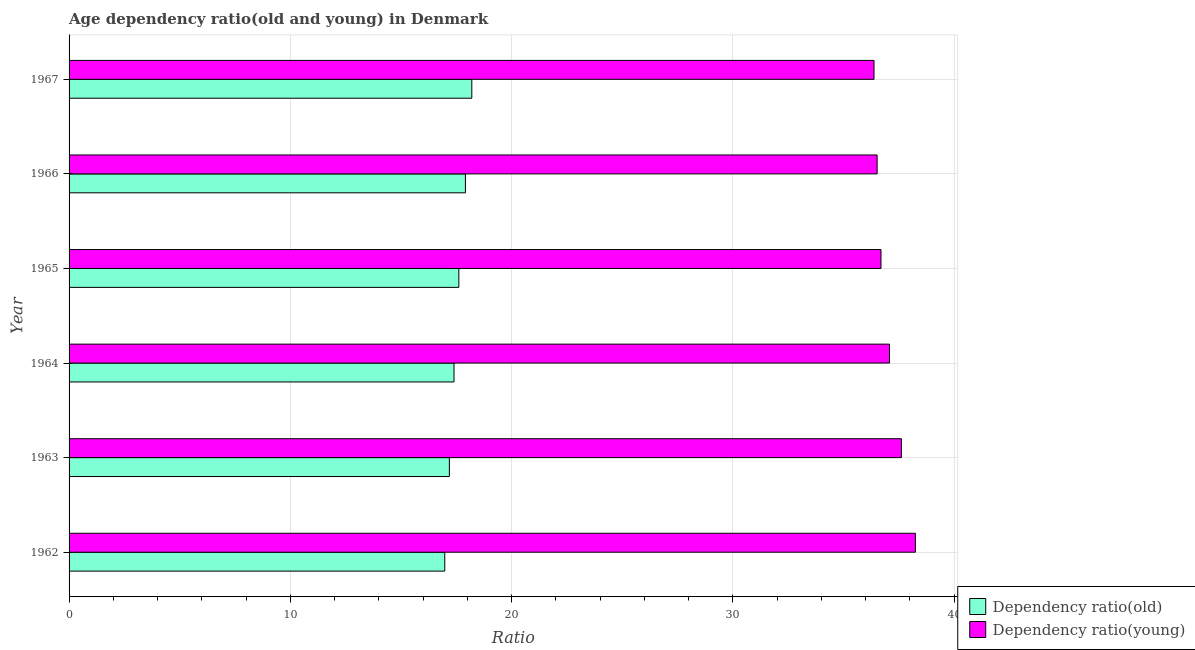Are the number of bars per tick equal to the number of legend labels?
Keep it short and to the point. Yes. Are the number of bars on each tick of the Y-axis equal?
Your answer should be compact. Yes. How many bars are there on the 5th tick from the top?
Give a very brief answer. 2. How many bars are there on the 3rd tick from the bottom?
Provide a short and direct response. 2. What is the label of the 6th group of bars from the top?
Ensure brevity in your answer.  1962. In how many cases, is the number of bars for a given year not equal to the number of legend labels?
Ensure brevity in your answer.  0. What is the age dependency ratio(young) in 1967?
Provide a succinct answer. 36.38. Across all years, what is the maximum age dependency ratio(old)?
Make the answer very short. 18.2. Across all years, what is the minimum age dependency ratio(old)?
Ensure brevity in your answer.  16.98. In which year was the age dependency ratio(old) maximum?
Make the answer very short. 1967. In which year was the age dependency ratio(old) minimum?
Offer a very short reply. 1962. What is the total age dependency ratio(old) in the graph?
Provide a short and direct response. 105.3. What is the difference between the age dependency ratio(young) in 1963 and that in 1965?
Your answer should be very brief. 0.92. What is the difference between the age dependency ratio(young) in 1962 and the age dependency ratio(old) in 1965?
Provide a short and direct response. 20.64. What is the average age dependency ratio(old) per year?
Your answer should be very brief. 17.55. In the year 1962, what is the difference between the age dependency ratio(young) and age dependency ratio(old)?
Provide a succinct answer. 21.27. Is the age dependency ratio(young) in 1962 less than that in 1965?
Ensure brevity in your answer.  No. Is the difference between the age dependency ratio(old) in 1963 and 1964 greater than the difference between the age dependency ratio(young) in 1963 and 1964?
Give a very brief answer. No. What is the difference between the highest and the second highest age dependency ratio(old)?
Offer a very short reply. 0.29. What is the difference between the highest and the lowest age dependency ratio(young)?
Ensure brevity in your answer.  1.87. What does the 2nd bar from the top in 1966 represents?
Your answer should be very brief. Dependency ratio(old). What does the 1st bar from the bottom in 1967 represents?
Your answer should be compact. Dependency ratio(old). How many bars are there?
Provide a succinct answer. 12. Are all the bars in the graph horizontal?
Provide a short and direct response. Yes. How many years are there in the graph?
Give a very brief answer. 6. Does the graph contain any zero values?
Keep it short and to the point. No. Where does the legend appear in the graph?
Your response must be concise. Bottom right. How many legend labels are there?
Make the answer very short. 2. How are the legend labels stacked?
Give a very brief answer. Vertical. What is the title of the graph?
Your answer should be very brief. Age dependency ratio(old and young) in Denmark. What is the label or title of the X-axis?
Keep it short and to the point. Ratio. What is the label or title of the Y-axis?
Make the answer very short. Year. What is the Ratio of Dependency ratio(old) in 1962?
Your answer should be compact. 16.98. What is the Ratio of Dependency ratio(young) in 1962?
Offer a very short reply. 38.25. What is the Ratio in Dependency ratio(old) in 1963?
Provide a succinct answer. 17.19. What is the Ratio in Dependency ratio(young) in 1963?
Your answer should be very brief. 37.62. What is the Ratio of Dependency ratio(old) in 1964?
Offer a terse response. 17.4. What is the Ratio in Dependency ratio(young) in 1964?
Offer a very short reply. 37.08. What is the Ratio of Dependency ratio(old) in 1965?
Provide a succinct answer. 17.62. What is the Ratio of Dependency ratio(young) in 1965?
Provide a succinct answer. 36.7. What is the Ratio in Dependency ratio(old) in 1966?
Keep it short and to the point. 17.91. What is the Ratio in Dependency ratio(young) in 1966?
Make the answer very short. 36.52. What is the Ratio in Dependency ratio(old) in 1967?
Your response must be concise. 18.2. What is the Ratio of Dependency ratio(young) in 1967?
Keep it short and to the point. 36.38. Across all years, what is the maximum Ratio of Dependency ratio(old)?
Provide a succinct answer. 18.2. Across all years, what is the maximum Ratio of Dependency ratio(young)?
Give a very brief answer. 38.25. Across all years, what is the minimum Ratio in Dependency ratio(old)?
Make the answer very short. 16.98. Across all years, what is the minimum Ratio in Dependency ratio(young)?
Give a very brief answer. 36.38. What is the total Ratio in Dependency ratio(old) in the graph?
Provide a succinct answer. 105.3. What is the total Ratio in Dependency ratio(young) in the graph?
Keep it short and to the point. 222.55. What is the difference between the Ratio in Dependency ratio(old) in 1962 and that in 1963?
Make the answer very short. -0.21. What is the difference between the Ratio of Dependency ratio(young) in 1962 and that in 1963?
Your answer should be compact. 0.63. What is the difference between the Ratio in Dependency ratio(old) in 1962 and that in 1964?
Make the answer very short. -0.42. What is the difference between the Ratio of Dependency ratio(young) in 1962 and that in 1964?
Offer a very short reply. 1.17. What is the difference between the Ratio of Dependency ratio(old) in 1962 and that in 1965?
Your answer should be very brief. -0.64. What is the difference between the Ratio in Dependency ratio(young) in 1962 and that in 1965?
Make the answer very short. 1.56. What is the difference between the Ratio in Dependency ratio(old) in 1962 and that in 1966?
Ensure brevity in your answer.  -0.93. What is the difference between the Ratio of Dependency ratio(young) in 1962 and that in 1966?
Ensure brevity in your answer.  1.73. What is the difference between the Ratio of Dependency ratio(old) in 1962 and that in 1967?
Give a very brief answer. -1.22. What is the difference between the Ratio of Dependency ratio(young) in 1962 and that in 1967?
Provide a short and direct response. 1.87. What is the difference between the Ratio of Dependency ratio(old) in 1963 and that in 1964?
Offer a very short reply. -0.21. What is the difference between the Ratio in Dependency ratio(young) in 1963 and that in 1964?
Provide a succinct answer. 0.54. What is the difference between the Ratio in Dependency ratio(old) in 1963 and that in 1965?
Give a very brief answer. -0.43. What is the difference between the Ratio of Dependency ratio(young) in 1963 and that in 1965?
Keep it short and to the point. 0.92. What is the difference between the Ratio of Dependency ratio(old) in 1963 and that in 1966?
Make the answer very short. -0.72. What is the difference between the Ratio of Dependency ratio(young) in 1963 and that in 1966?
Give a very brief answer. 1.1. What is the difference between the Ratio in Dependency ratio(old) in 1963 and that in 1967?
Make the answer very short. -1.01. What is the difference between the Ratio of Dependency ratio(young) in 1963 and that in 1967?
Your answer should be very brief. 1.24. What is the difference between the Ratio in Dependency ratio(old) in 1964 and that in 1965?
Your answer should be very brief. -0.22. What is the difference between the Ratio of Dependency ratio(young) in 1964 and that in 1965?
Your response must be concise. 0.39. What is the difference between the Ratio in Dependency ratio(old) in 1964 and that in 1966?
Offer a terse response. -0.52. What is the difference between the Ratio in Dependency ratio(young) in 1964 and that in 1966?
Your answer should be very brief. 0.56. What is the difference between the Ratio in Dependency ratio(old) in 1964 and that in 1967?
Provide a short and direct response. -0.8. What is the difference between the Ratio in Dependency ratio(young) in 1964 and that in 1967?
Your answer should be compact. 0.7. What is the difference between the Ratio in Dependency ratio(old) in 1965 and that in 1966?
Ensure brevity in your answer.  -0.3. What is the difference between the Ratio in Dependency ratio(young) in 1965 and that in 1966?
Your answer should be compact. 0.17. What is the difference between the Ratio in Dependency ratio(old) in 1965 and that in 1967?
Make the answer very short. -0.59. What is the difference between the Ratio of Dependency ratio(young) in 1965 and that in 1967?
Your answer should be very brief. 0.31. What is the difference between the Ratio in Dependency ratio(old) in 1966 and that in 1967?
Offer a terse response. -0.29. What is the difference between the Ratio of Dependency ratio(young) in 1966 and that in 1967?
Your response must be concise. 0.14. What is the difference between the Ratio in Dependency ratio(old) in 1962 and the Ratio in Dependency ratio(young) in 1963?
Your answer should be compact. -20.64. What is the difference between the Ratio in Dependency ratio(old) in 1962 and the Ratio in Dependency ratio(young) in 1964?
Your response must be concise. -20.1. What is the difference between the Ratio of Dependency ratio(old) in 1962 and the Ratio of Dependency ratio(young) in 1965?
Offer a very short reply. -19.72. What is the difference between the Ratio of Dependency ratio(old) in 1962 and the Ratio of Dependency ratio(young) in 1966?
Provide a short and direct response. -19.54. What is the difference between the Ratio of Dependency ratio(old) in 1962 and the Ratio of Dependency ratio(young) in 1967?
Keep it short and to the point. -19.4. What is the difference between the Ratio of Dependency ratio(old) in 1963 and the Ratio of Dependency ratio(young) in 1964?
Your answer should be compact. -19.89. What is the difference between the Ratio in Dependency ratio(old) in 1963 and the Ratio in Dependency ratio(young) in 1965?
Offer a very short reply. -19.51. What is the difference between the Ratio of Dependency ratio(old) in 1963 and the Ratio of Dependency ratio(young) in 1966?
Your answer should be very brief. -19.33. What is the difference between the Ratio of Dependency ratio(old) in 1963 and the Ratio of Dependency ratio(young) in 1967?
Your answer should be compact. -19.19. What is the difference between the Ratio of Dependency ratio(old) in 1964 and the Ratio of Dependency ratio(young) in 1965?
Provide a succinct answer. -19.3. What is the difference between the Ratio in Dependency ratio(old) in 1964 and the Ratio in Dependency ratio(young) in 1966?
Offer a very short reply. -19.12. What is the difference between the Ratio of Dependency ratio(old) in 1964 and the Ratio of Dependency ratio(young) in 1967?
Give a very brief answer. -18.98. What is the difference between the Ratio in Dependency ratio(old) in 1965 and the Ratio in Dependency ratio(young) in 1966?
Your answer should be compact. -18.91. What is the difference between the Ratio of Dependency ratio(old) in 1965 and the Ratio of Dependency ratio(young) in 1967?
Offer a terse response. -18.76. What is the difference between the Ratio of Dependency ratio(old) in 1966 and the Ratio of Dependency ratio(young) in 1967?
Ensure brevity in your answer.  -18.47. What is the average Ratio of Dependency ratio(old) per year?
Provide a succinct answer. 17.55. What is the average Ratio in Dependency ratio(young) per year?
Offer a very short reply. 37.09. In the year 1962, what is the difference between the Ratio of Dependency ratio(old) and Ratio of Dependency ratio(young)?
Your answer should be compact. -21.27. In the year 1963, what is the difference between the Ratio in Dependency ratio(old) and Ratio in Dependency ratio(young)?
Your response must be concise. -20.43. In the year 1964, what is the difference between the Ratio in Dependency ratio(old) and Ratio in Dependency ratio(young)?
Ensure brevity in your answer.  -19.68. In the year 1965, what is the difference between the Ratio in Dependency ratio(old) and Ratio in Dependency ratio(young)?
Ensure brevity in your answer.  -19.08. In the year 1966, what is the difference between the Ratio of Dependency ratio(old) and Ratio of Dependency ratio(young)?
Make the answer very short. -18.61. In the year 1967, what is the difference between the Ratio of Dependency ratio(old) and Ratio of Dependency ratio(young)?
Offer a very short reply. -18.18. What is the ratio of the Ratio of Dependency ratio(old) in 1962 to that in 1963?
Your response must be concise. 0.99. What is the ratio of the Ratio in Dependency ratio(young) in 1962 to that in 1963?
Give a very brief answer. 1.02. What is the ratio of the Ratio in Dependency ratio(old) in 1962 to that in 1964?
Provide a short and direct response. 0.98. What is the ratio of the Ratio of Dependency ratio(young) in 1962 to that in 1964?
Give a very brief answer. 1.03. What is the ratio of the Ratio in Dependency ratio(old) in 1962 to that in 1965?
Your answer should be very brief. 0.96. What is the ratio of the Ratio of Dependency ratio(young) in 1962 to that in 1965?
Offer a very short reply. 1.04. What is the ratio of the Ratio in Dependency ratio(old) in 1962 to that in 1966?
Offer a very short reply. 0.95. What is the ratio of the Ratio of Dependency ratio(young) in 1962 to that in 1966?
Make the answer very short. 1.05. What is the ratio of the Ratio of Dependency ratio(old) in 1962 to that in 1967?
Offer a very short reply. 0.93. What is the ratio of the Ratio of Dependency ratio(young) in 1962 to that in 1967?
Your answer should be very brief. 1.05. What is the ratio of the Ratio of Dependency ratio(old) in 1963 to that in 1964?
Offer a very short reply. 0.99. What is the ratio of the Ratio of Dependency ratio(young) in 1963 to that in 1964?
Offer a very short reply. 1.01. What is the ratio of the Ratio in Dependency ratio(old) in 1963 to that in 1965?
Give a very brief answer. 0.98. What is the ratio of the Ratio in Dependency ratio(young) in 1963 to that in 1965?
Offer a very short reply. 1.03. What is the ratio of the Ratio of Dependency ratio(old) in 1963 to that in 1966?
Your response must be concise. 0.96. What is the ratio of the Ratio of Dependency ratio(old) in 1963 to that in 1967?
Provide a short and direct response. 0.94. What is the ratio of the Ratio in Dependency ratio(young) in 1963 to that in 1967?
Your answer should be compact. 1.03. What is the ratio of the Ratio of Dependency ratio(old) in 1964 to that in 1965?
Make the answer very short. 0.99. What is the ratio of the Ratio in Dependency ratio(young) in 1964 to that in 1965?
Offer a very short reply. 1.01. What is the ratio of the Ratio in Dependency ratio(old) in 1964 to that in 1966?
Offer a very short reply. 0.97. What is the ratio of the Ratio of Dependency ratio(young) in 1964 to that in 1966?
Make the answer very short. 1.02. What is the ratio of the Ratio in Dependency ratio(old) in 1964 to that in 1967?
Ensure brevity in your answer.  0.96. What is the ratio of the Ratio in Dependency ratio(young) in 1964 to that in 1967?
Offer a very short reply. 1.02. What is the ratio of the Ratio of Dependency ratio(old) in 1965 to that in 1966?
Provide a succinct answer. 0.98. What is the ratio of the Ratio in Dependency ratio(young) in 1965 to that in 1966?
Ensure brevity in your answer.  1. What is the ratio of the Ratio of Dependency ratio(old) in 1965 to that in 1967?
Offer a terse response. 0.97. What is the ratio of the Ratio of Dependency ratio(young) in 1965 to that in 1967?
Your answer should be compact. 1.01. What is the ratio of the Ratio in Dependency ratio(old) in 1966 to that in 1967?
Make the answer very short. 0.98. What is the ratio of the Ratio of Dependency ratio(young) in 1966 to that in 1967?
Your answer should be compact. 1. What is the difference between the highest and the second highest Ratio of Dependency ratio(old)?
Your answer should be compact. 0.29. What is the difference between the highest and the second highest Ratio of Dependency ratio(young)?
Offer a terse response. 0.63. What is the difference between the highest and the lowest Ratio of Dependency ratio(old)?
Offer a terse response. 1.22. What is the difference between the highest and the lowest Ratio in Dependency ratio(young)?
Provide a succinct answer. 1.87. 